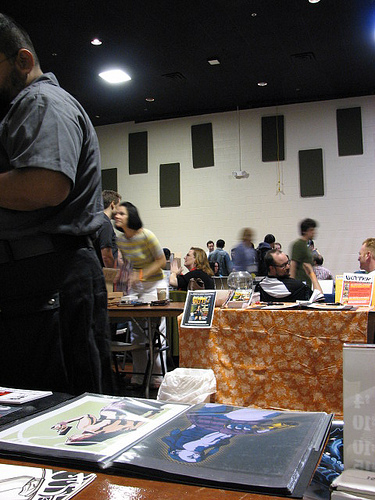<image>
Is the light next to the art? No. The light is not positioned next to the art. They are located in different areas of the scene. 